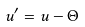Convert formula to latex. <formula><loc_0><loc_0><loc_500><loc_500>u ^ { \prime } = u - \Theta</formula> 